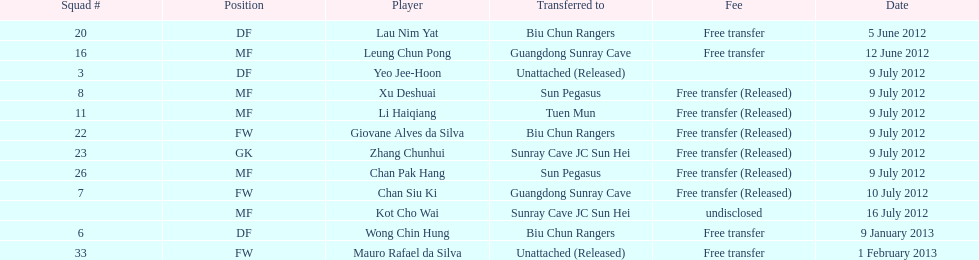Who is the first player listed? Lau Nim Yat. 